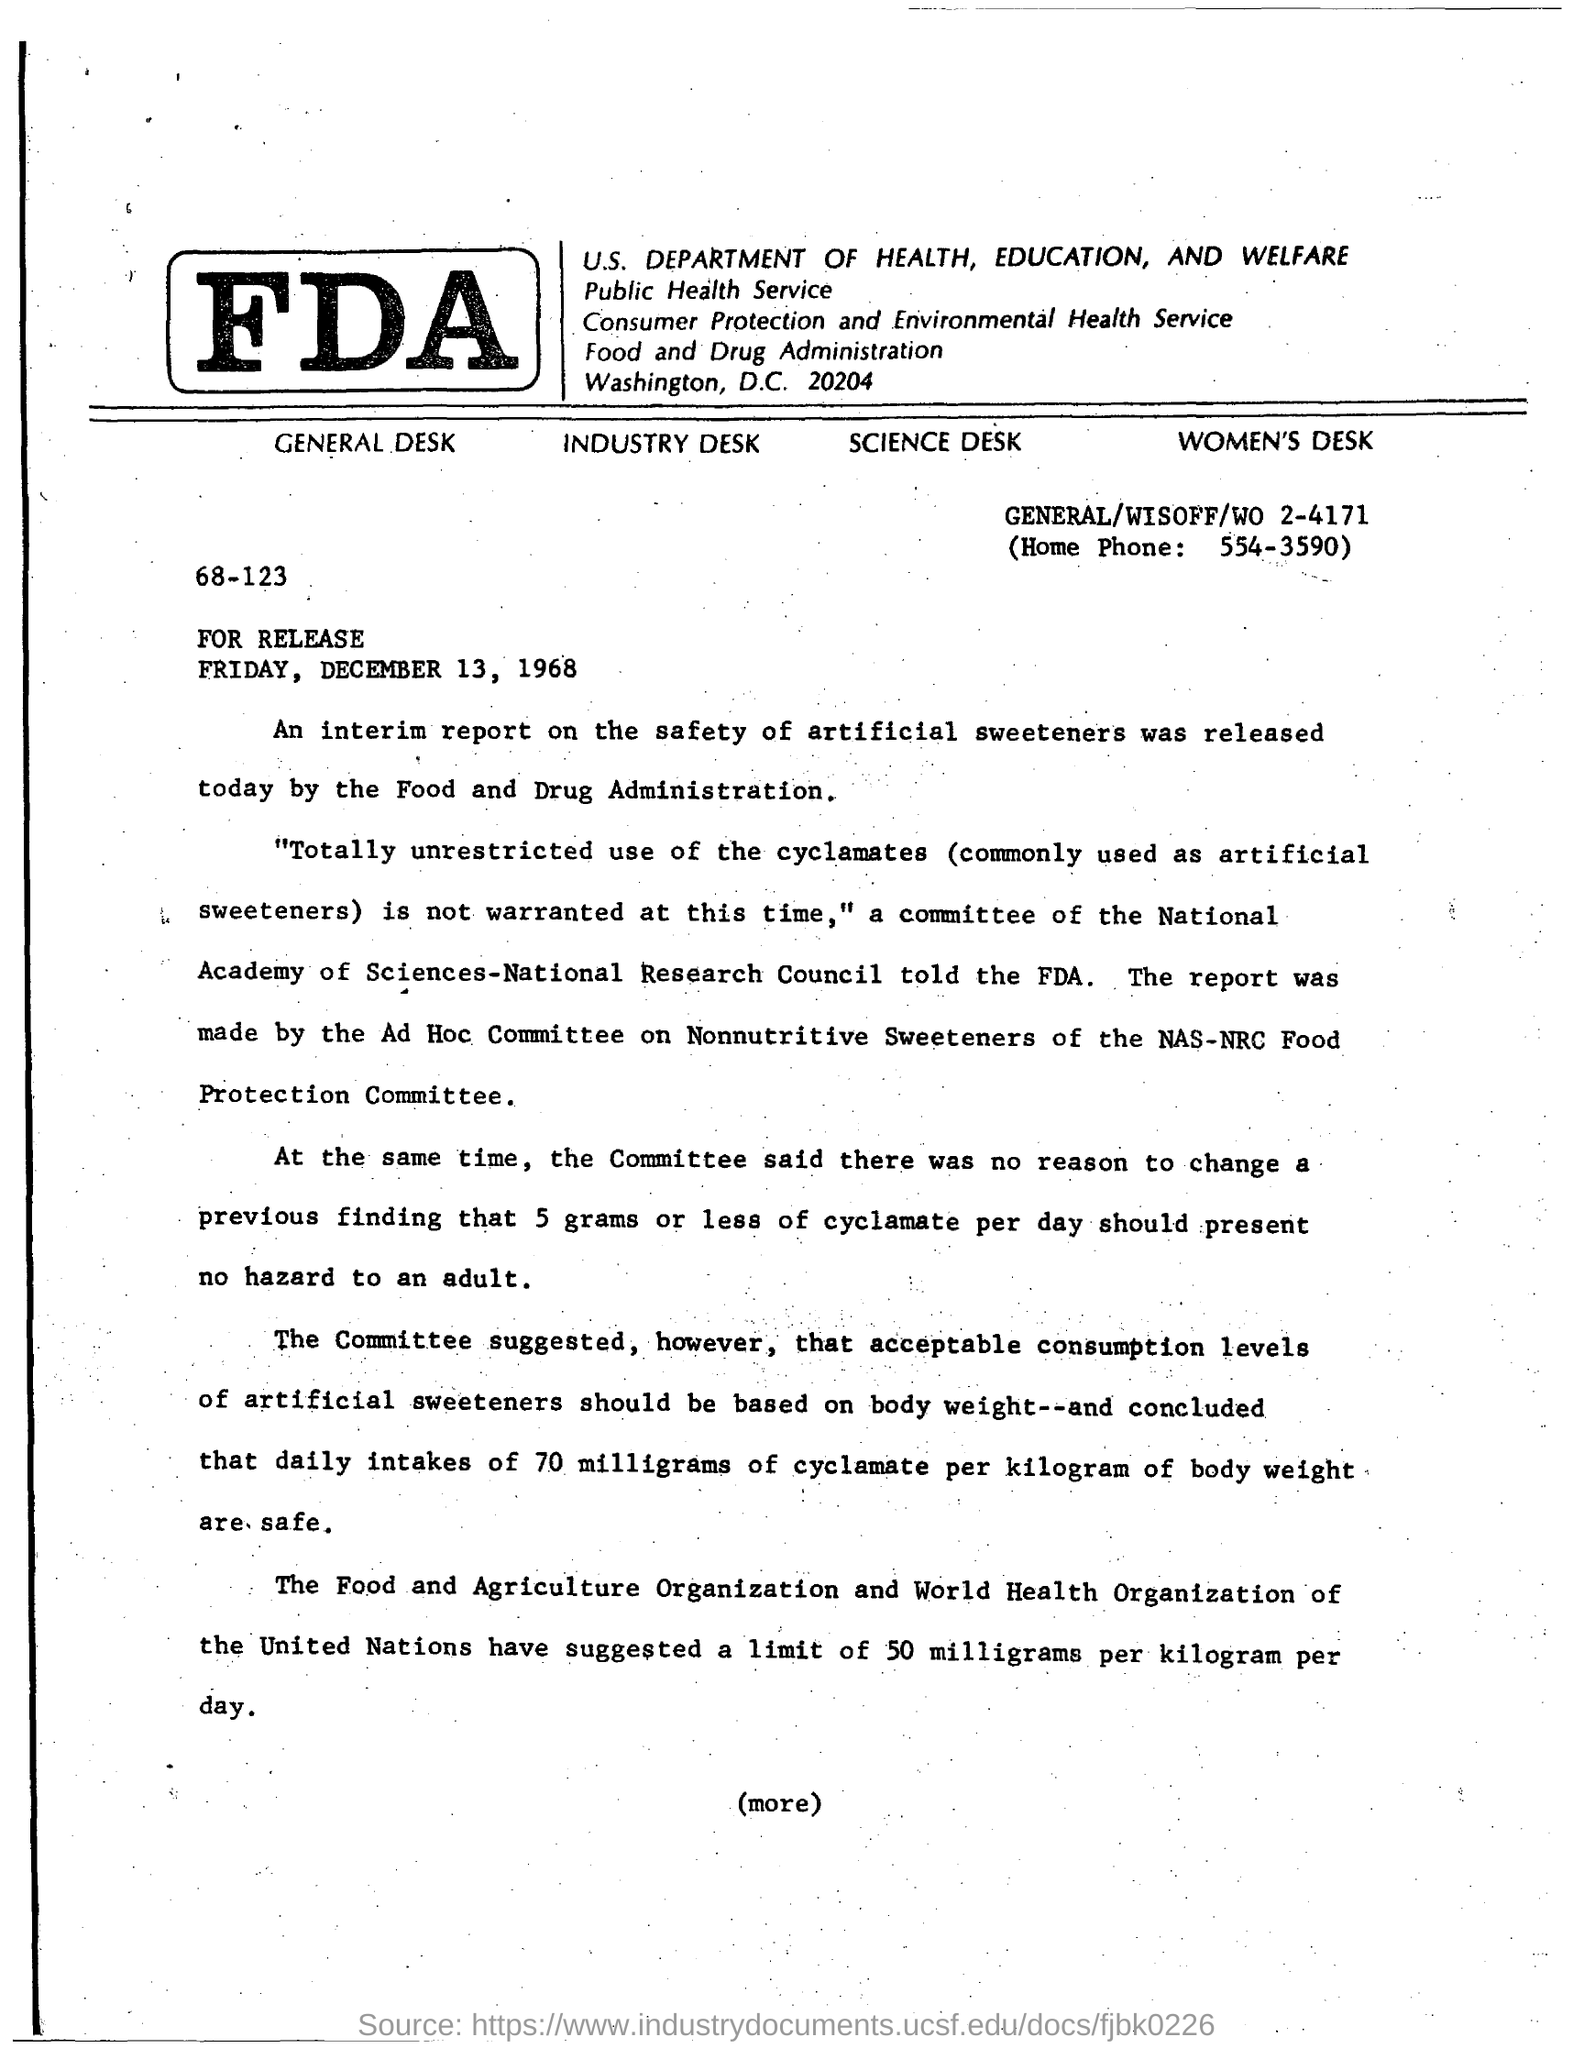Give some essential details in this illustration. The home phone number is 554-3590. 